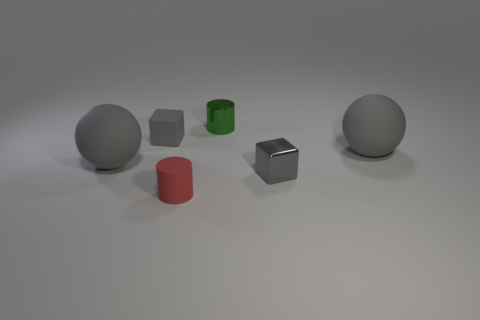Add 3 tiny red cylinders. How many objects exist? 9 Subtract all balls. How many objects are left? 4 Subtract all big gray objects. Subtract all large rubber balls. How many objects are left? 2 Add 4 green objects. How many green objects are left? 5 Add 4 red rubber things. How many red rubber things exist? 5 Subtract 0 brown blocks. How many objects are left? 6 